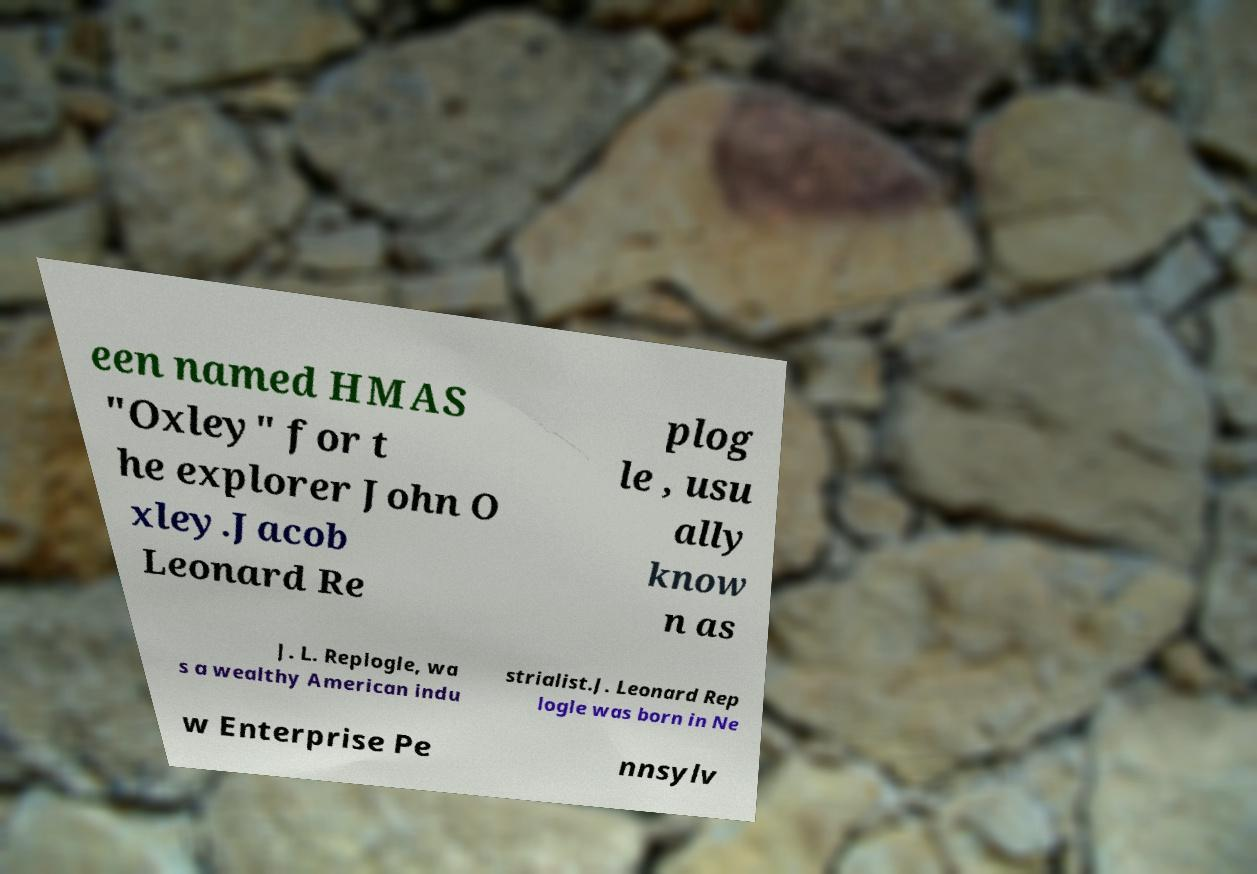There's text embedded in this image that I need extracted. Can you transcribe it verbatim? een named HMAS "Oxley" for t he explorer John O xley.Jacob Leonard Re plog le , usu ally know n as J. L. Replogle, wa s a wealthy American indu strialist.J. Leonard Rep logle was born in Ne w Enterprise Pe nnsylv 